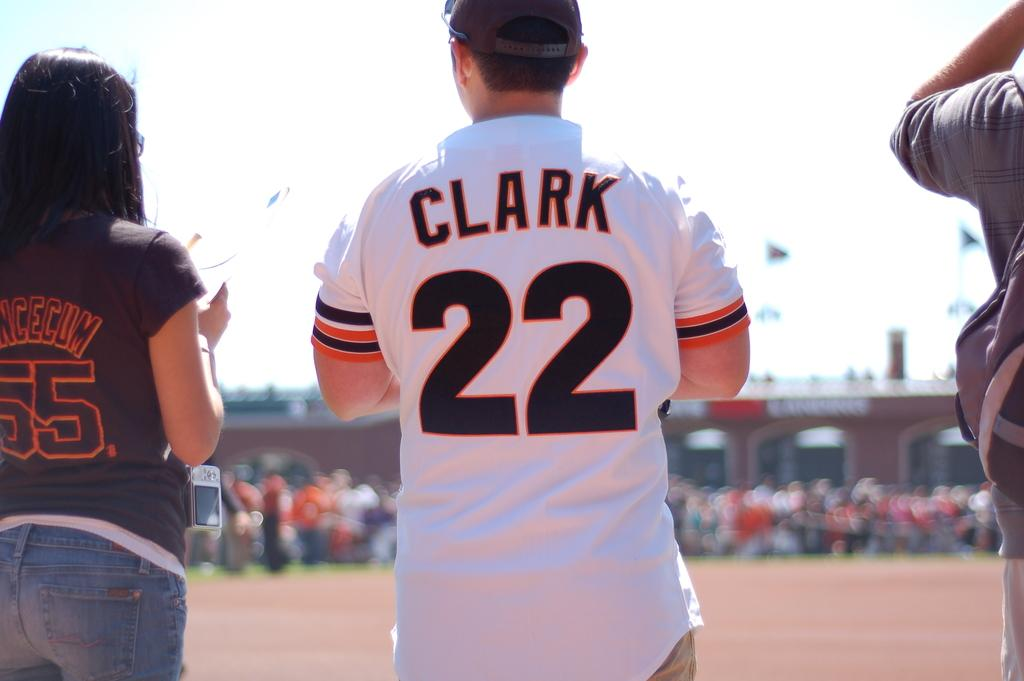<image>
Offer a succinct explanation of the picture presented. A man in a baseball cap with his back facing wearing a jersey with the writing CLARK and number 22 with a women with a shirt reading 55 beside him 